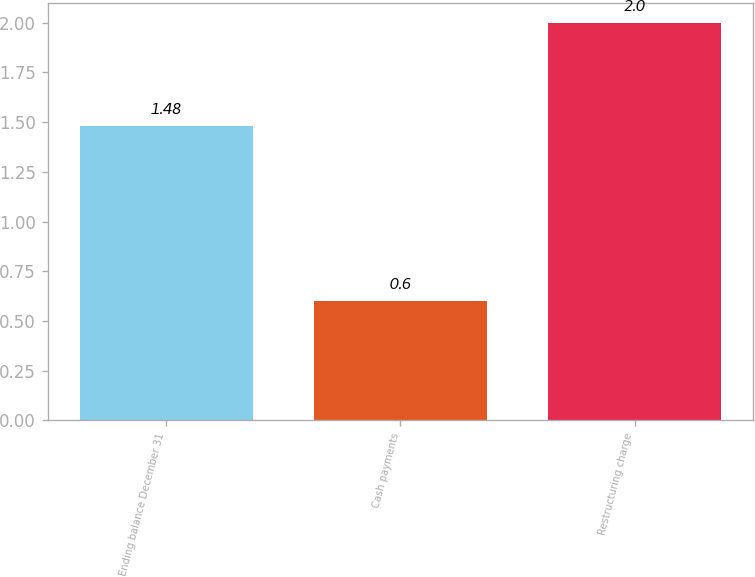Convert chart to OTSL. <chart><loc_0><loc_0><loc_500><loc_500><bar_chart><fcel>Ending balance December 31<fcel>Cash payments<fcel>Restructuring charge<nl><fcel>1.48<fcel>0.6<fcel>2<nl></chart> 